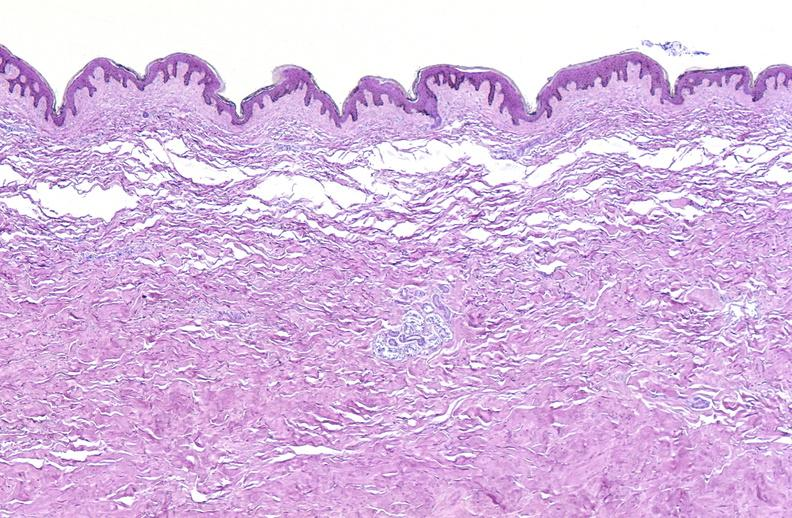does this image show scleroderma?
Answer the question using a single word or phrase. Yes 